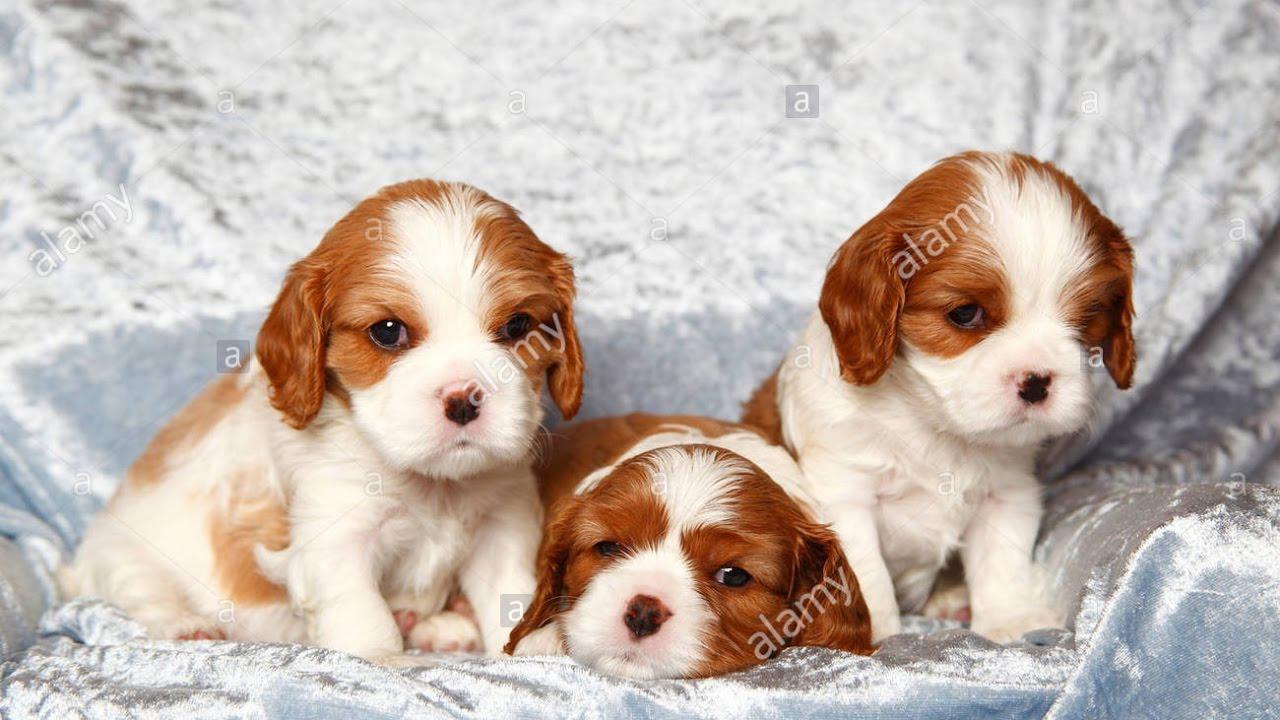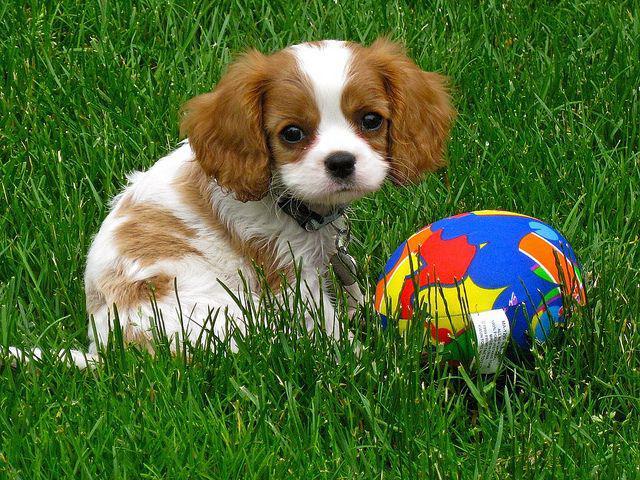The first image is the image on the left, the second image is the image on the right. Given the left and right images, does the statement "There is at least one image that shows exactly one dog in the grass." hold true? Answer yes or no. Yes. The first image is the image on the left, the second image is the image on the right. Evaluate the accuracy of this statement regarding the images: "There is at most 2 dogs.". Is it true? Answer yes or no. No. 